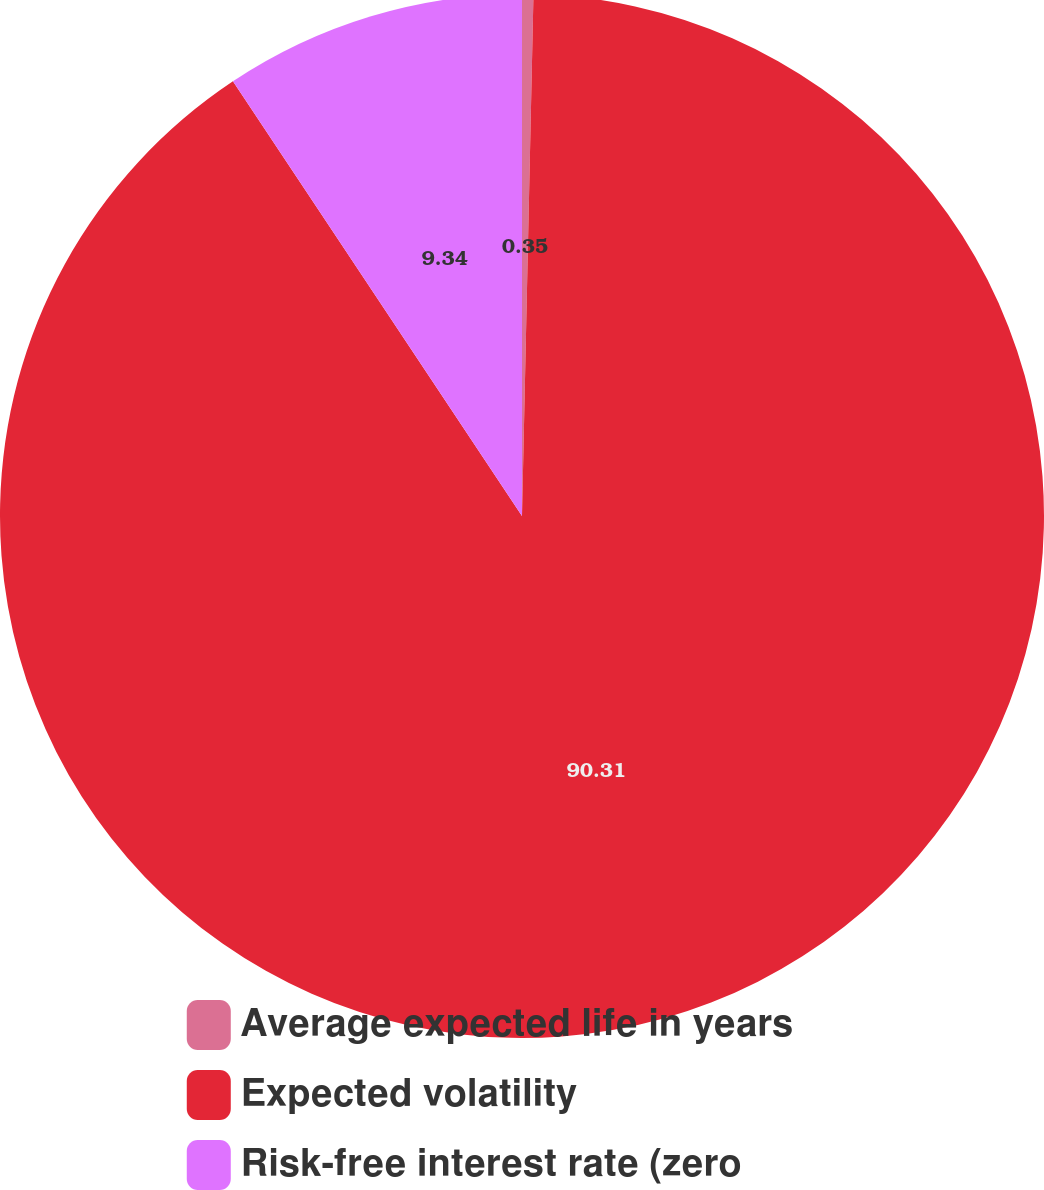<chart> <loc_0><loc_0><loc_500><loc_500><pie_chart><fcel>Average expected life in years<fcel>Expected volatility<fcel>Risk-free interest rate (zero<nl><fcel>0.35%<fcel>90.31%<fcel>9.34%<nl></chart> 